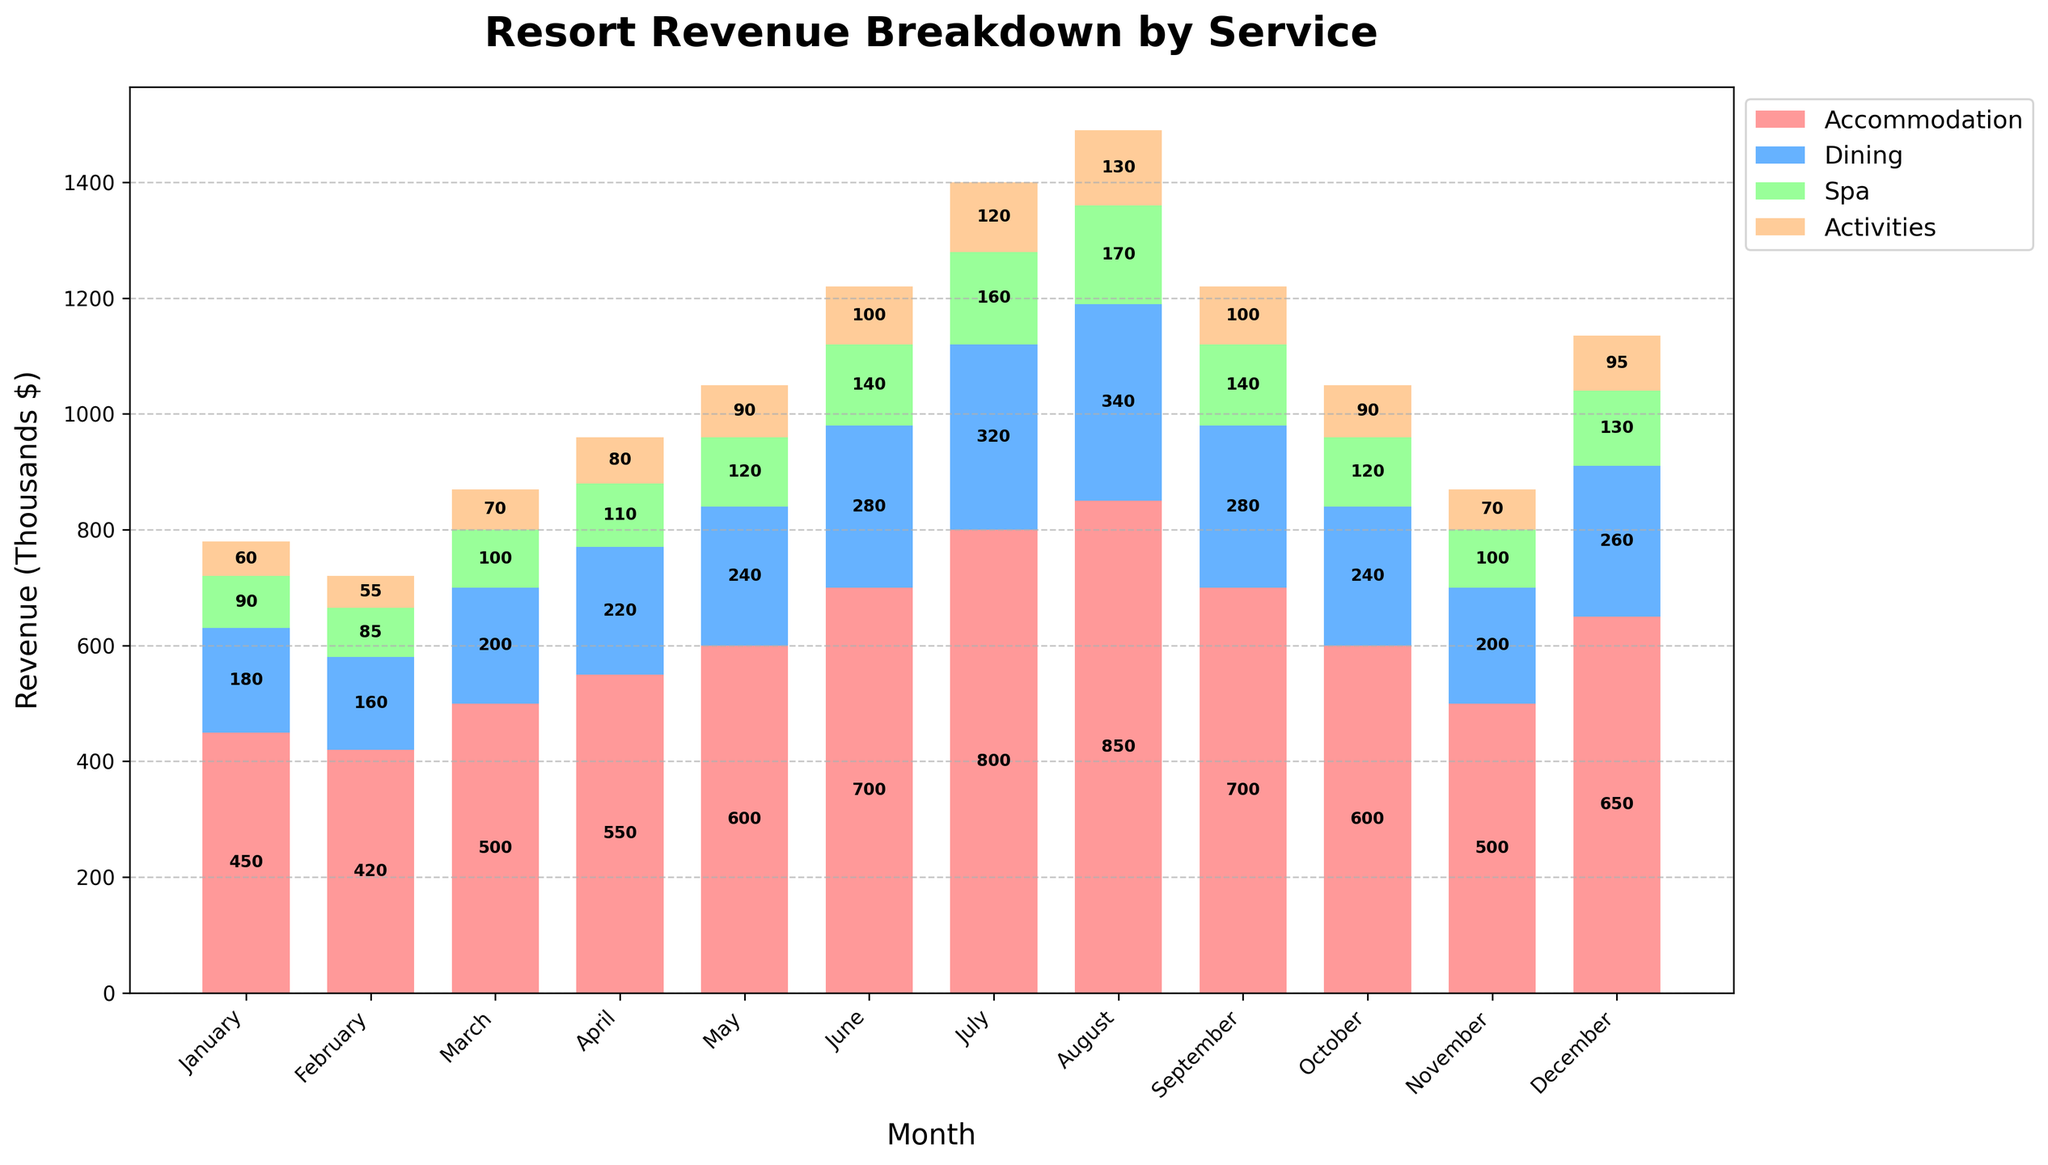What month had the highest total revenue from all resort services combined? By summing each month's revenue from the services (Accommodation, Dining, Spa, Activities) and comparing the totals, August has the highest total revenue. Sum for August: 850 + 340 + 170 + 130 = 1490 (thousands $).
Answer: August Which service consistently generated the most revenue every month? By comparing the heights of the bars for each service across all months, Accommodation consistently sits on top of all others.
Answer: Accommodation In which month did the resort generate the lowest revenue from dining services? By looking at the height of the Dining segment (blue) for each month, February has the smallest blue bar. Dining revenue in February: 160 (thousands $).
Answer: February What is the average monthly revenue from spa services across the year? Sum the Spa revenue for all months and divide by 12. Total Spa revenue: 90 + 85 + 100 + 110 + 120 + 140 + 160 + 170 + 140 + 120 + 100 + 130 = 1465. So, average: 1465 / 12 ≈ 122.08 (thousands $).
Answer: 122.08 How does the total revenue in December compare to the total revenue in June? Calculate the total revenue for December and June, then compare. December: 650 + 260 + 130 + 95 = 1135 (thousands $), June: 700 + 280 + 140 + 100 = 1220 (thousands $). December's total revenue is 85 (thousands $) less than June’s.
Answer: December's total is 85 less than June's What is the percentage increase in total revenue from January to July? Calculate total revenue for January and July, then find the percentage increase. January: 450 + 180 + 90 + 60 = 780 (thousands $), July: 800 + 320 + 160 + 120 = 1400 (thousands $). Percentage increase: ((1400 - 780) / 780) * 100 ≈ 79.49%.
Answer: 79.49% Which month saw the highest combined revenue from spa and activities services? By summing the Spa and Activities revenue for each month and comparing, August has the highest combined. Spa: 170, Activities: 130. Combined: 170 + 130 = 300 (thousands $).
Answer: August In how many months did the revenue from activities exceed 100 thousand dollars? Activities revenue exceeds 100 (thousands $) in July (120), August (130), and December (95), so that counts to 3 months.
Answer: 3 Did the total revenue from accommodation services always exceed 400 thousand dollars? By checking the Accommodation revenue for each month, yes, it is always above 400 thousand dollars.
Answer: Yes Which service showed the most obvious seasonal peak in the middle of the year? By observing the bars for each service, Accommodation has the most noticeable peak in the middle months (June, July, August).
Answer: Accommodation 